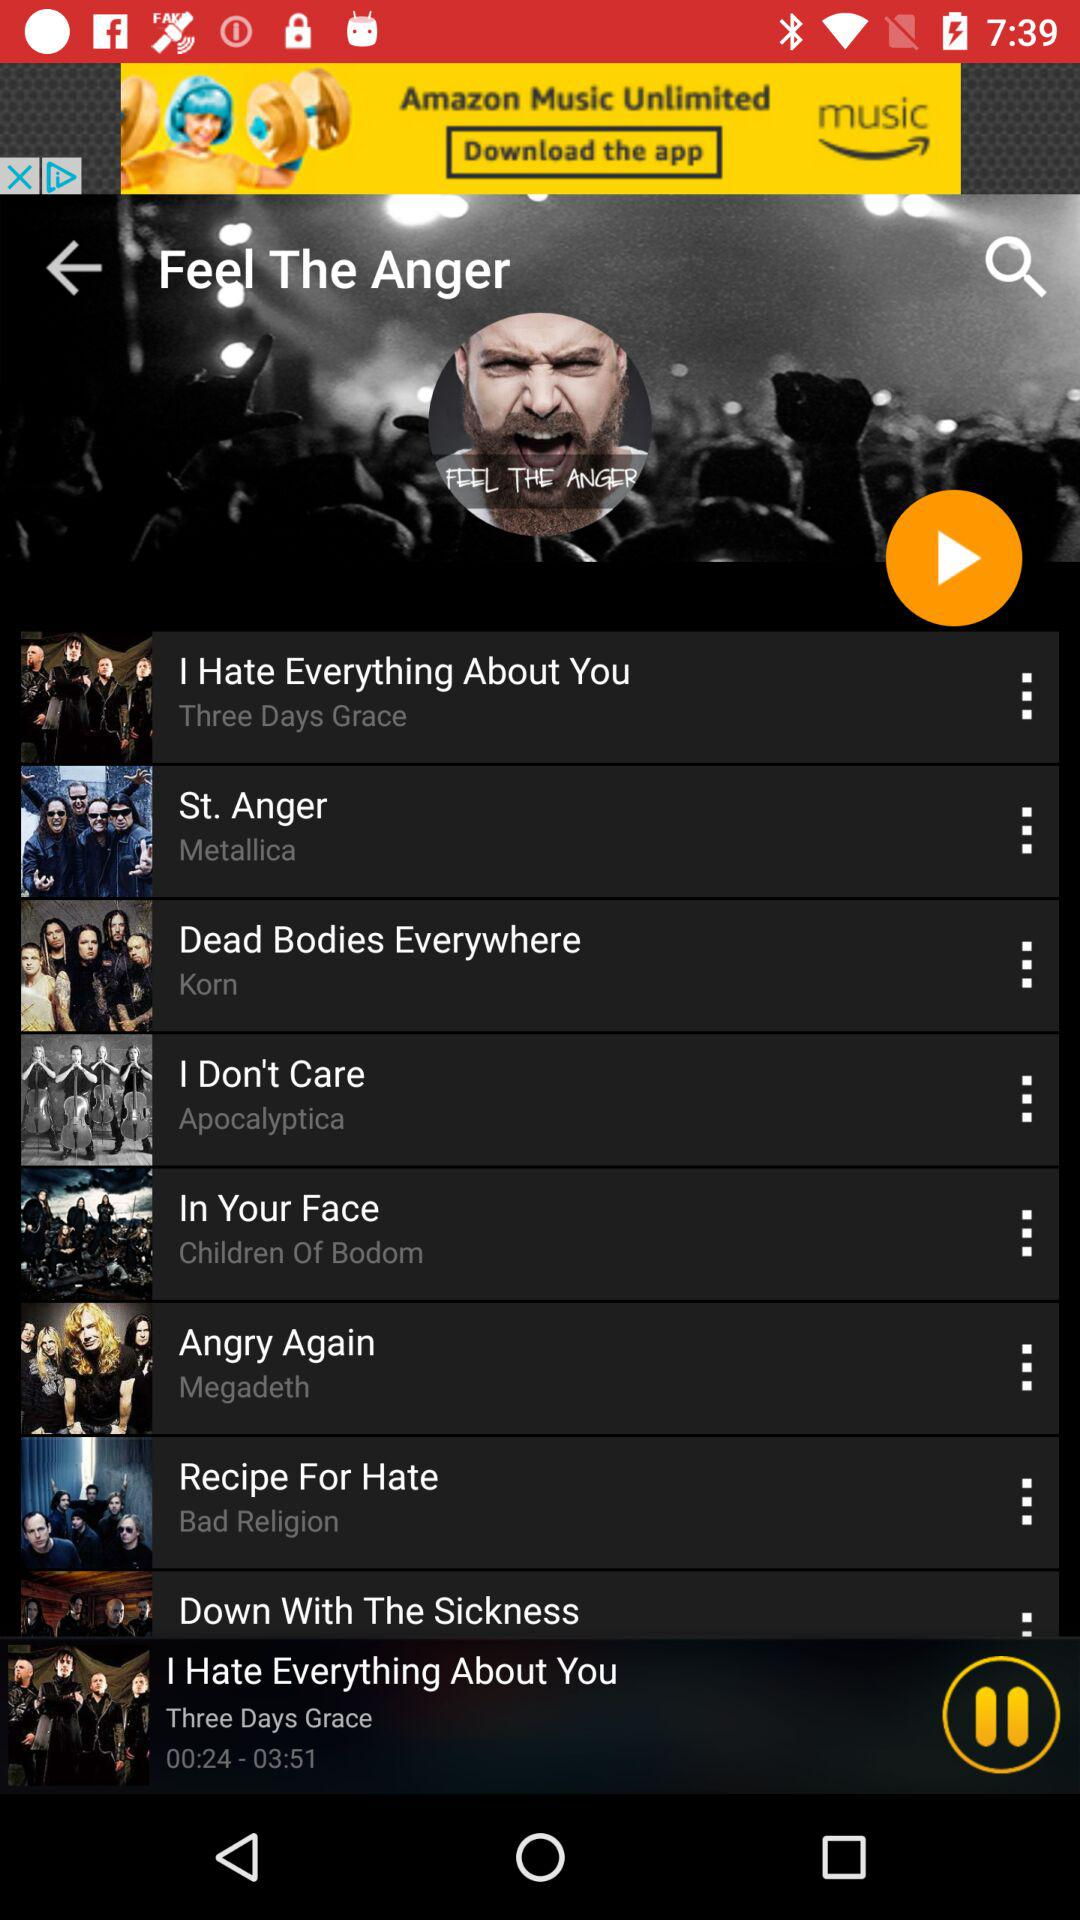Who sings "Down With The Sickness"?
When the provided information is insufficient, respond with <no answer>. <no answer> 